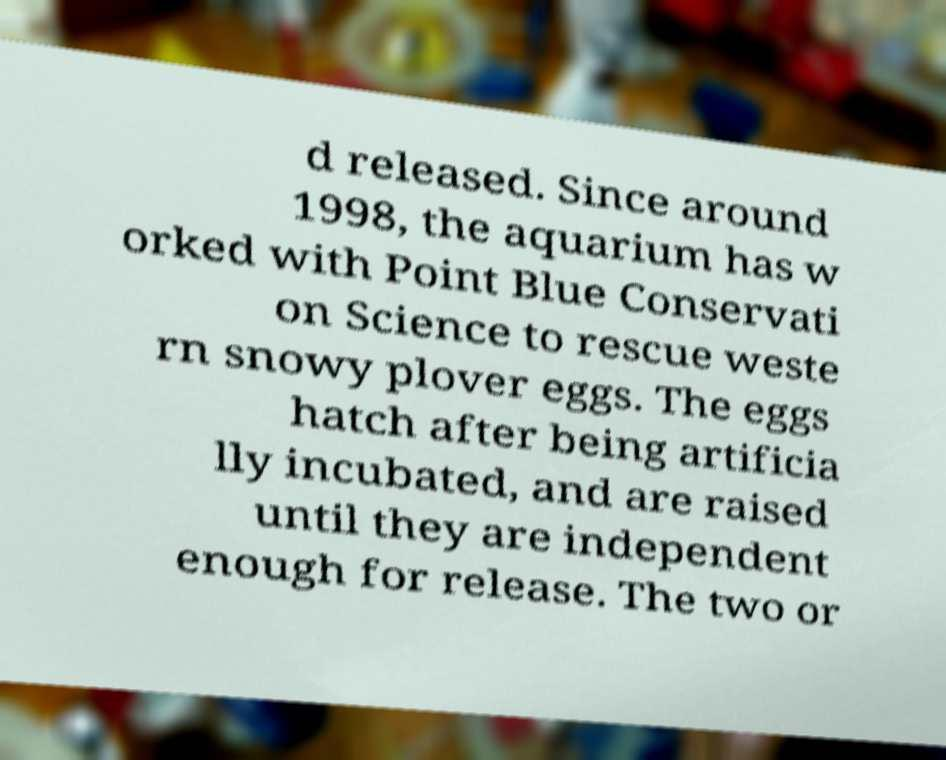What messages or text are displayed in this image? I need them in a readable, typed format. d released. Since around 1998, the aquarium has w orked with Point Blue Conservati on Science to rescue weste rn snowy plover eggs. The eggs hatch after being artificia lly incubated, and are raised until they are independent enough for release. The two or 